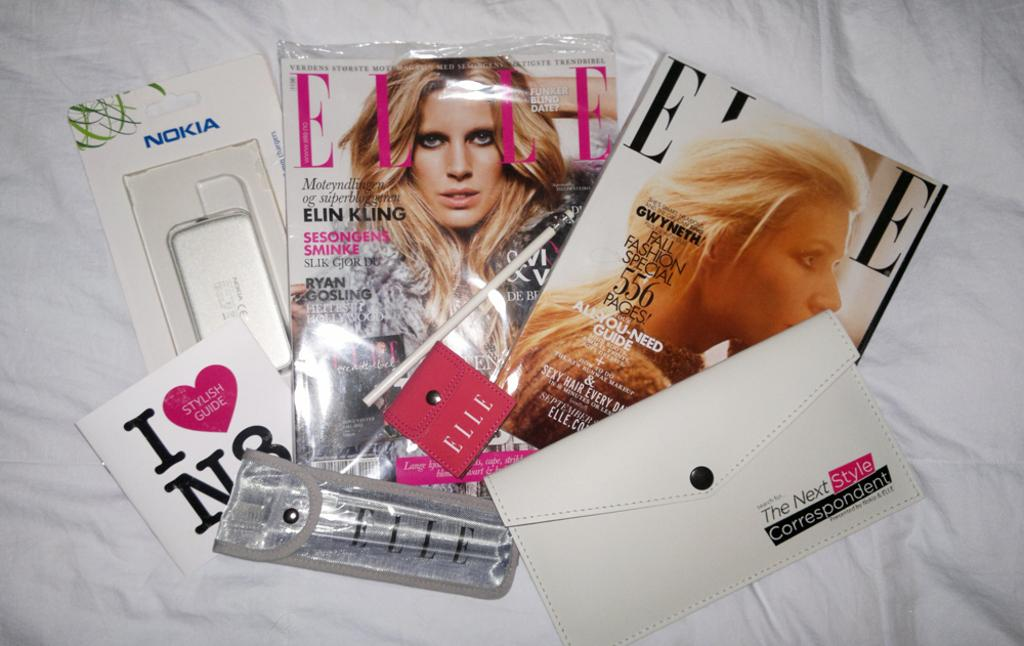What type of reading material can be seen in the image? There are magazines and a book in the image. What other items are present in the image? There is a purse, a cover, and a packet in the image. On what surface are these items placed? The objects are on a white cloth. How does the tongue help in reading the book in the image? The tongue does not help in reading the book in the image, as it is not involved in the process of reading. 